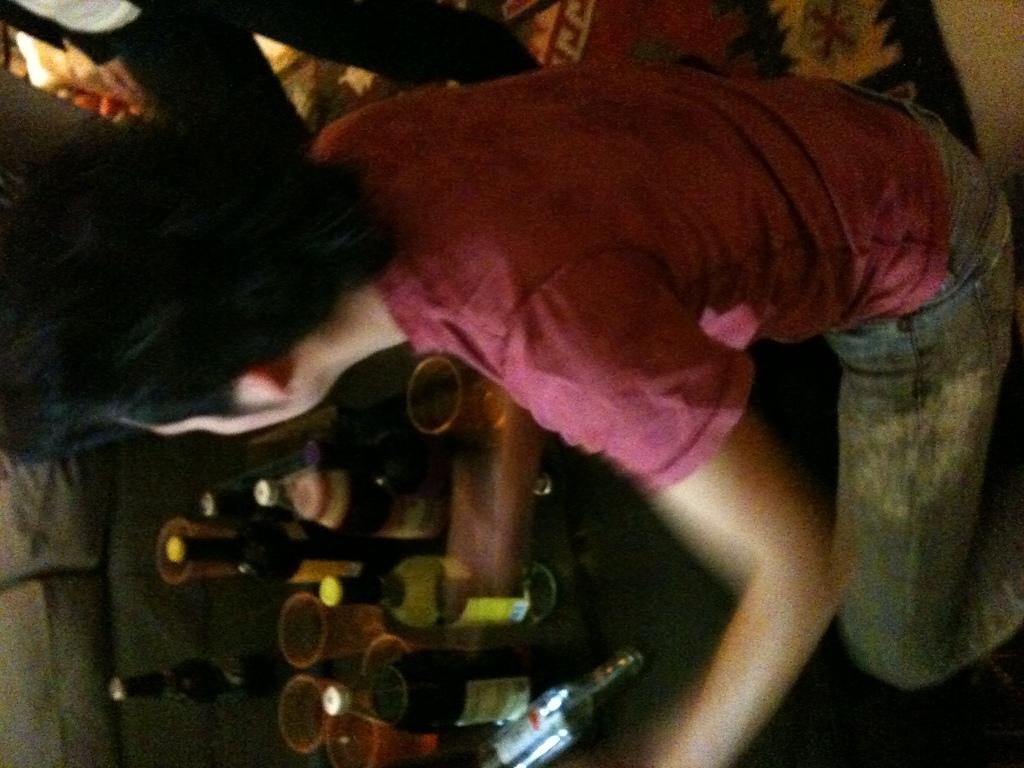How many people are in the image? There are two persons in the image. What can be seen besides the people in the image? There are bottles, glasses, and other objects in the image. Is there any quicksand visible in the image? No, there is no quicksand present in the image. How many balls can be seen in the image? There is no mention of balls in the provided facts, so we cannot determine if any are present in the image. 